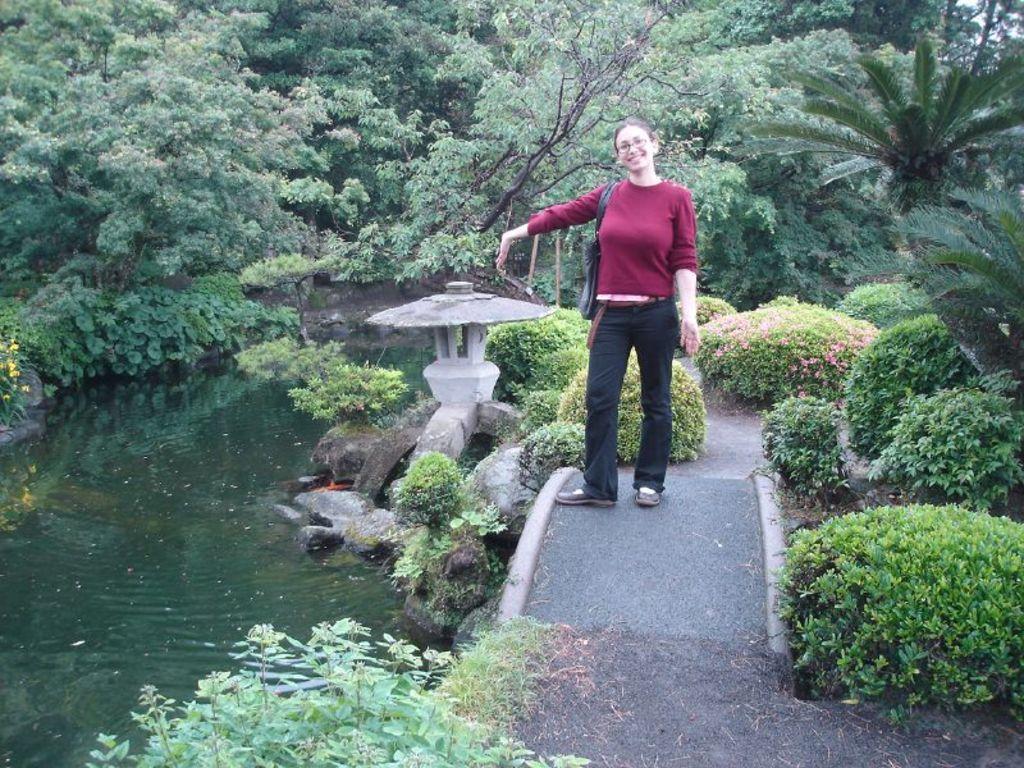How would you summarize this image in a sentence or two? The woman in the center of the picture wearing a maroon t-shirt and black pant is standing beside the trees and she is smiling. Beside her, we see water and this water might be in a pond. There are many trees in the background and this picture might be clicked in the garden. 